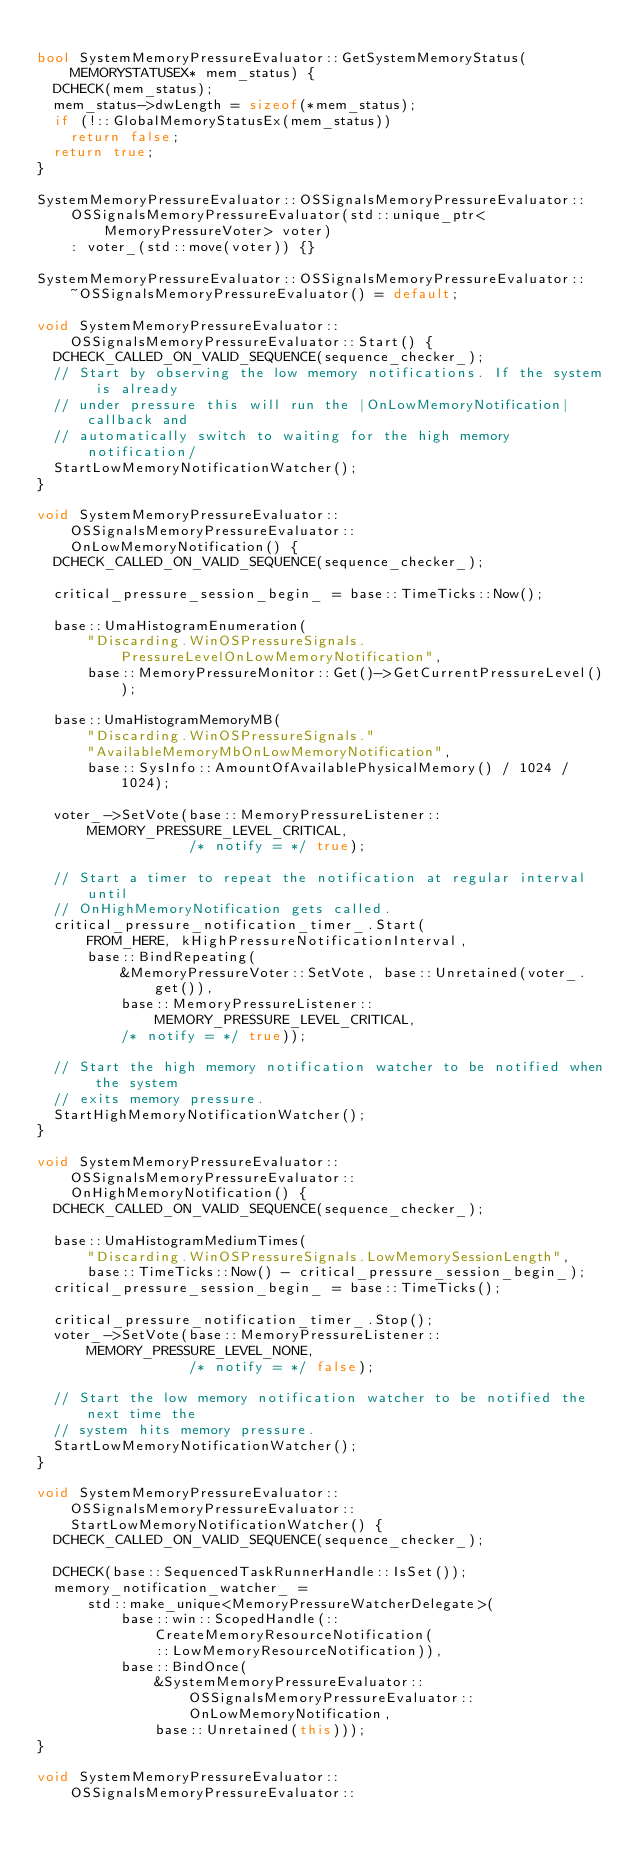<code> <loc_0><loc_0><loc_500><loc_500><_C++_>
bool SystemMemoryPressureEvaluator::GetSystemMemoryStatus(
    MEMORYSTATUSEX* mem_status) {
  DCHECK(mem_status);
  mem_status->dwLength = sizeof(*mem_status);
  if (!::GlobalMemoryStatusEx(mem_status))
    return false;
  return true;
}

SystemMemoryPressureEvaluator::OSSignalsMemoryPressureEvaluator::
    OSSignalsMemoryPressureEvaluator(std::unique_ptr<MemoryPressureVoter> voter)
    : voter_(std::move(voter)) {}

SystemMemoryPressureEvaluator::OSSignalsMemoryPressureEvaluator::
    ~OSSignalsMemoryPressureEvaluator() = default;

void SystemMemoryPressureEvaluator::OSSignalsMemoryPressureEvaluator::Start() {
  DCHECK_CALLED_ON_VALID_SEQUENCE(sequence_checker_);
  // Start by observing the low memory notifications. If the system is already
  // under pressure this will run the |OnLowMemoryNotification| callback and
  // automatically switch to waiting for the high memory notification/
  StartLowMemoryNotificationWatcher();
}

void SystemMemoryPressureEvaluator::OSSignalsMemoryPressureEvaluator::
    OnLowMemoryNotification() {
  DCHECK_CALLED_ON_VALID_SEQUENCE(sequence_checker_);

  critical_pressure_session_begin_ = base::TimeTicks::Now();

  base::UmaHistogramEnumeration(
      "Discarding.WinOSPressureSignals.PressureLevelOnLowMemoryNotification",
      base::MemoryPressureMonitor::Get()->GetCurrentPressureLevel());

  base::UmaHistogramMemoryMB(
      "Discarding.WinOSPressureSignals."
      "AvailableMemoryMbOnLowMemoryNotification",
      base::SysInfo::AmountOfAvailablePhysicalMemory() / 1024 / 1024);

  voter_->SetVote(base::MemoryPressureListener::MEMORY_PRESSURE_LEVEL_CRITICAL,
                  /* notify = */ true);

  // Start a timer to repeat the notification at regular interval until
  // OnHighMemoryNotification gets called.
  critical_pressure_notification_timer_.Start(
      FROM_HERE, kHighPressureNotificationInterval,
      base::BindRepeating(
          &MemoryPressureVoter::SetVote, base::Unretained(voter_.get()),
          base::MemoryPressureListener::MEMORY_PRESSURE_LEVEL_CRITICAL,
          /* notify = */ true));

  // Start the high memory notification watcher to be notified when the system
  // exits memory pressure.
  StartHighMemoryNotificationWatcher();
}

void SystemMemoryPressureEvaluator::OSSignalsMemoryPressureEvaluator::
    OnHighMemoryNotification() {
  DCHECK_CALLED_ON_VALID_SEQUENCE(sequence_checker_);

  base::UmaHistogramMediumTimes(
      "Discarding.WinOSPressureSignals.LowMemorySessionLength",
      base::TimeTicks::Now() - critical_pressure_session_begin_);
  critical_pressure_session_begin_ = base::TimeTicks();

  critical_pressure_notification_timer_.Stop();
  voter_->SetVote(base::MemoryPressureListener::MEMORY_PRESSURE_LEVEL_NONE,
                  /* notify = */ false);

  // Start the low memory notification watcher to be notified the next time the
  // system hits memory pressure.
  StartLowMemoryNotificationWatcher();
}

void SystemMemoryPressureEvaluator::OSSignalsMemoryPressureEvaluator::
    StartLowMemoryNotificationWatcher() {
  DCHECK_CALLED_ON_VALID_SEQUENCE(sequence_checker_);

  DCHECK(base::SequencedTaskRunnerHandle::IsSet());
  memory_notification_watcher_ =
      std::make_unique<MemoryPressureWatcherDelegate>(
          base::win::ScopedHandle(::CreateMemoryResourceNotification(
              ::LowMemoryResourceNotification)),
          base::BindOnce(
              &SystemMemoryPressureEvaluator::OSSignalsMemoryPressureEvaluator::
                  OnLowMemoryNotification,
              base::Unretained(this)));
}

void SystemMemoryPressureEvaluator::OSSignalsMemoryPressureEvaluator::</code> 